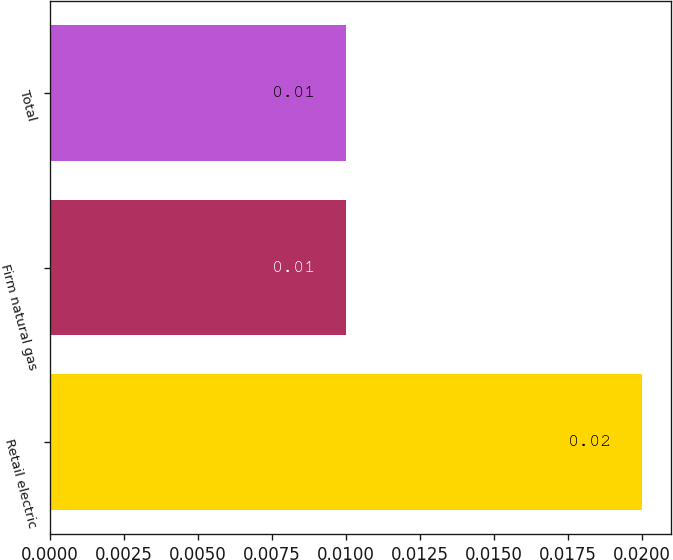Convert chart to OTSL. <chart><loc_0><loc_0><loc_500><loc_500><bar_chart><fcel>Retail electric<fcel>Firm natural gas<fcel>Total<nl><fcel>0.02<fcel>0.01<fcel>0.01<nl></chart> 